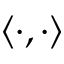Convert formula to latex. <formula><loc_0><loc_0><loc_500><loc_500>\langle \cdot , \cdot \rangle</formula> 